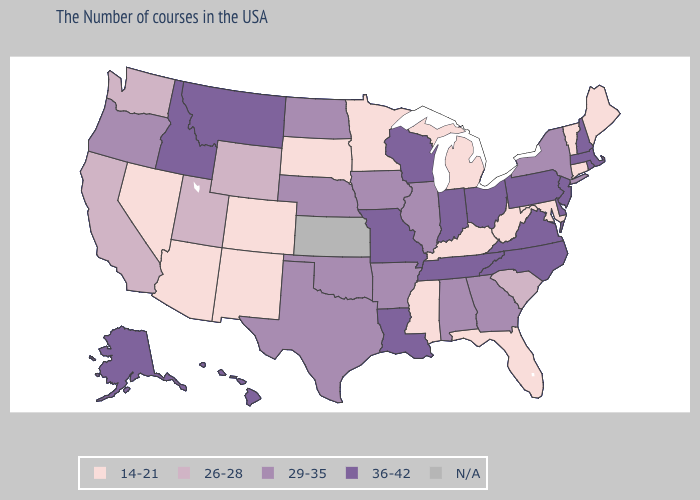Does Nevada have the highest value in the USA?
Answer briefly. No. Does Ohio have the highest value in the MidWest?
Short answer required. Yes. Among the states that border Delaware , does Maryland have the highest value?
Concise answer only. No. What is the value of Arizona?
Write a very short answer. 14-21. Among the states that border Connecticut , which have the lowest value?
Be succinct. New York. Name the states that have a value in the range 36-42?
Keep it brief. Massachusetts, Rhode Island, New Hampshire, New Jersey, Delaware, Pennsylvania, Virginia, North Carolina, Ohio, Indiana, Tennessee, Wisconsin, Louisiana, Missouri, Montana, Idaho, Alaska, Hawaii. Among the states that border Georgia , does Florida have the lowest value?
Quick response, please. Yes. What is the lowest value in states that border Vermont?
Be succinct. 29-35. Does the first symbol in the legend represent the smallest category?
Write a very short answer. Yes. Does South Dakota have the lowest value in the USA?
Give a very brief answer. Yes. Among the states that border Pennsylvania , does New Jersey have the lowest value?
Write a very short answer. No. Which states have the lowest value in the South?
Short answer required. Maryland, West Virginia, Florida, Kentucky, Mississippi. Is the legend a continuous bar?
Short answer required. No. Among the states that border Vermont , does Massachusetts have the lowest value?
Write a very short answer. No. 